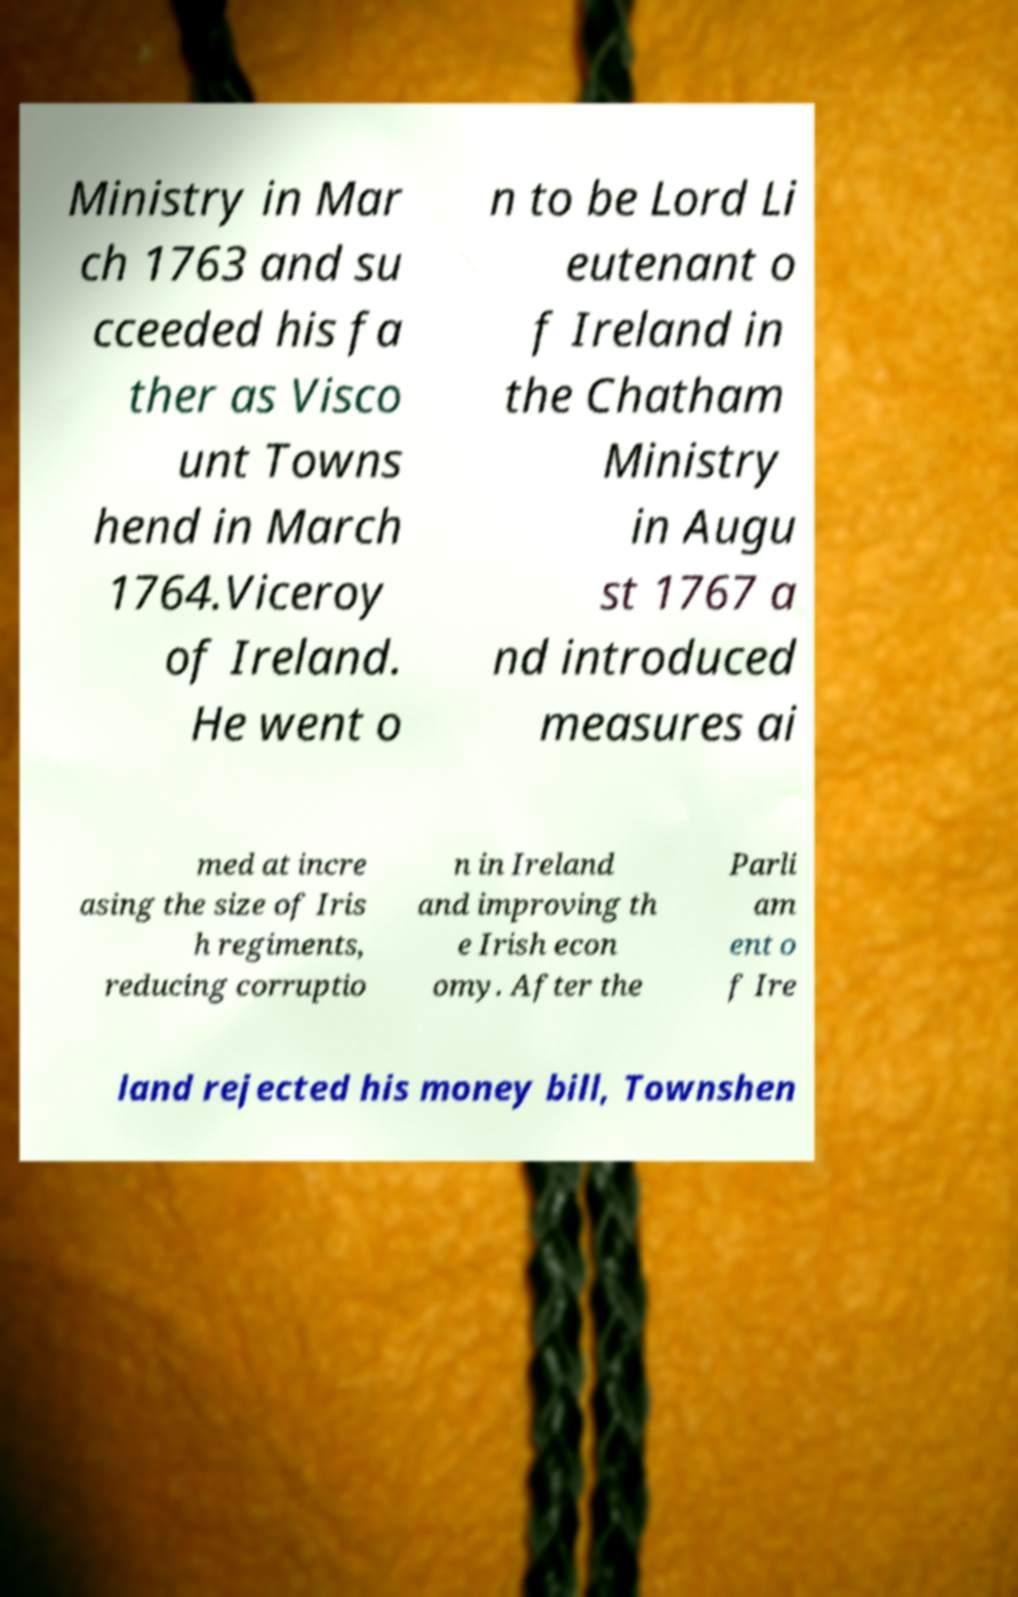There's text embedded in this image that I need extracted. Can you transcribe it verbatim? Ministry in Mar ch 1763 and su cceeded his fa ther as Visco unt Towns hend in March 1764.Viceroy of Ireland. He went o n to be Lord Li eutenant o f Ireland in the Chatham Ministry in Augu st 1767 a nd introduced measures ai med at incre asing the size of Iris h regiments, reducing corruptio n in Ireland and improving th e Irish econ omy. After the Parli am ent o f Ire land rejected his money bill, Townshen 